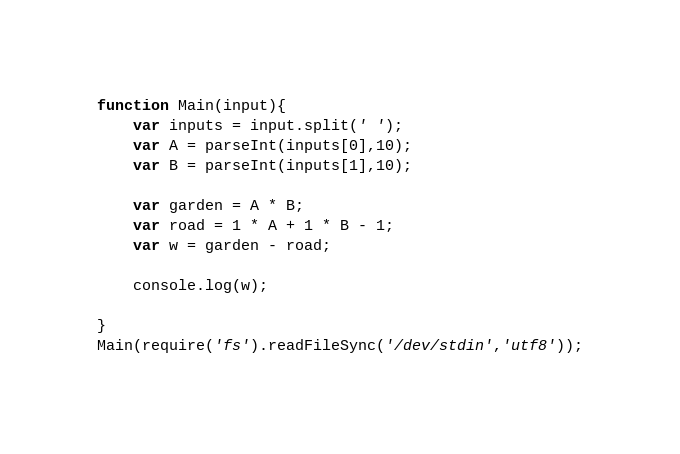Convert code to text. <code><loc_0><loc_0><loc_500><loc_500><_JavaScript_>function Main(input){
    var inputs = input.split(' ');
    var A = parseInt(inputs[0],10);
    var B = parseInt(inputs[1],10);

    var garden = A * B;
    var road = 1 * A + 1 * B - 1;
    var w = garden - road;

    console.log(w);

}
Main(require('fs').readFileSync('/dev/stdin','utf8'));

</code> 